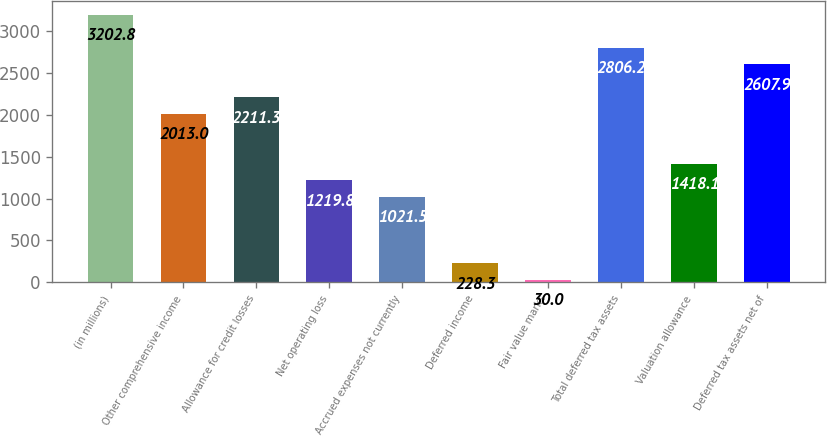<chart> <loc_0><loc_0><loc_500><loc_500><bar_chart><fcel>(in millions)<fcel>Other comprehensive income<fcel>Allowance for credit losses<fcel>Net operating loss<fcel>Accrued expenses not currently<fcel>Deferred income<fcel>Fair value marks<fcel>Total deferred tax assets<fcel>Valuation allowance<fcel>Deferred tax assets net of<nl><fcel>3202.8<fcel>2013<fcel>2211.3<fcel>1219.8<fcel>1021.5<fcel>228.3<fcel>30<fcel>2806.2<fcel>1418.1<fcel>2607.9<nl></chart> 